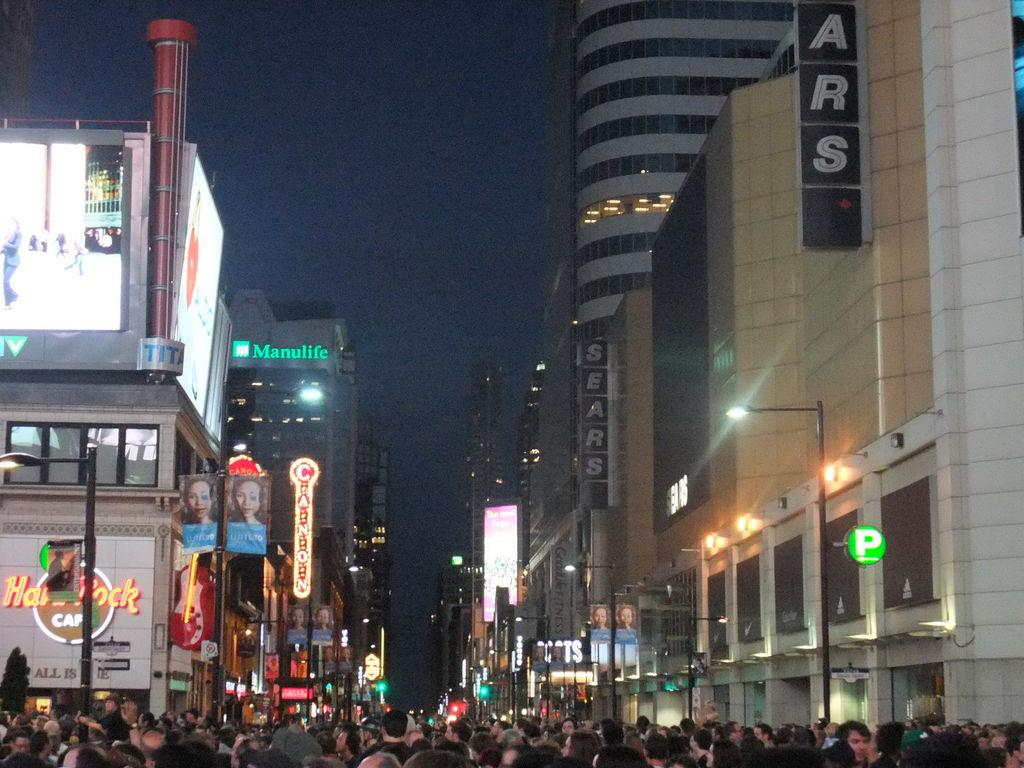Provide a one-sentence caption for the provided image. A busy area in the city shows many buildings including The Hard Rock Cafe. 